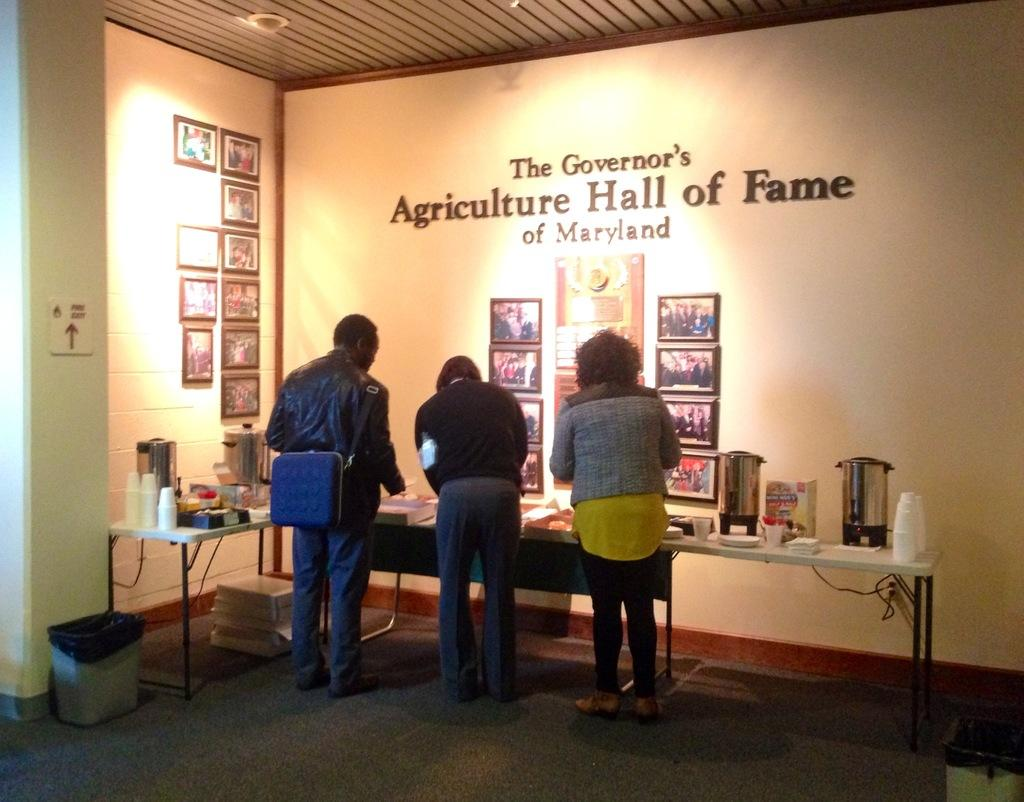<image>
Render a clear and concise summary of the photo. people at a table at the governors agriculture hall of fame of maryland 